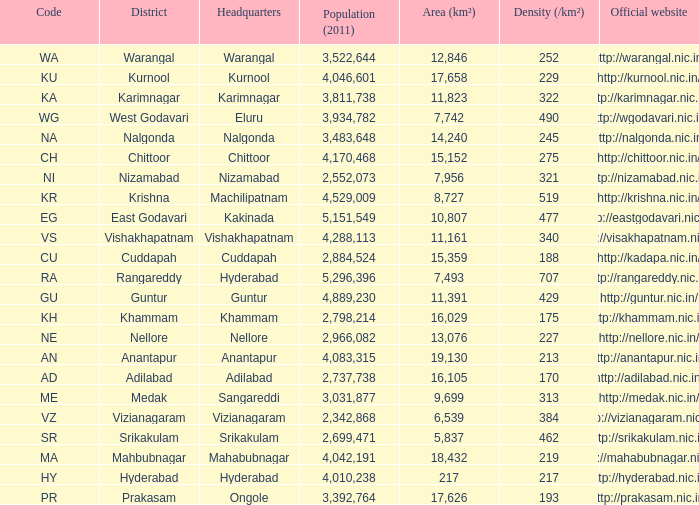What is the sum of the area values for districts having density over 462 and websites of http://krishna.nic.in/? 8727.0. 